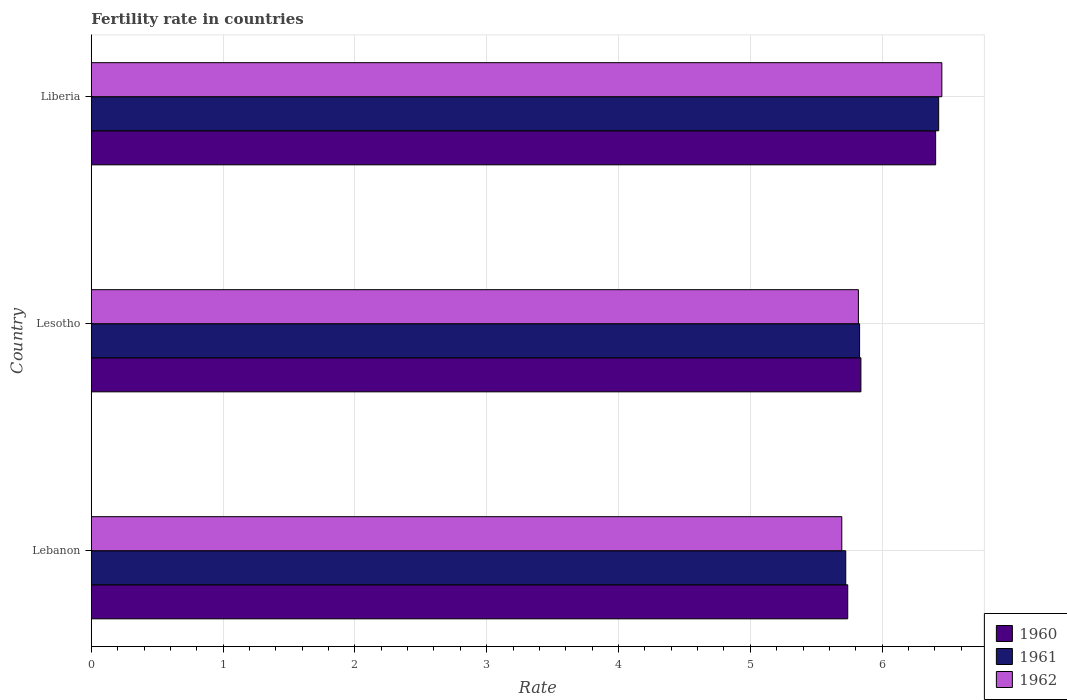How many different coloured bars are there?
Ensure brevity in your answer.  3. How many groups of bars are there?
Offer a terse response. 3. Are the number of bars on each tick of the Y-axis equal?
Your response must be concise. Yes. How many bars are there on the 1st tick from the bottom?
Your answer should be very brief. 3. What is the label of the 3rd group of bars from the top?
Your answer should be compact. Lebanon. In how many cases, is the number of bars for a given country not equal to the number of legend labels?
Your response must be concise. 0. What is the fertility rate in 1961 in Liberia?
Ensure brevity in your answer.  6.43. Across all countries, what is the maximum fertility rate in 1961?
Your answer should be compact. 6.43. Across all countries, what is the minimum fertility rate in 1960?
Provide a short and direct response. 5.74. In which country was the fertility rate in 1962 maximum?
Provide a succinct answer. Liberia. In which country was the fertility rate in 1962 minimum?
Offer a terse response. Lebanon. What is the total fertility rate in 1960 in the graph?
Provide a short and direct response. 17.98. What is the difference between the fertility rate in 1962 in Lebanon and that in Lesotho?
Offer a terse response. -0.13. What is the difference between the fertility rate in 1961 in Lesotho and the fertility rate in 1960 in Lebanon?
Your answer should be very brief. 0.09. What is the average fertility rate in 1962 per country?
Keep it short and to the point. 5.99. What is the difference between the fertility rate in 1960 and fertility rate in 1962 in Lebanon?
Your answer should be very brief. 0.04. In how many countries, is the fertility rate in 1960 greater than 2 ?
Ensure brevity in your answer.  3. What is the ratio of the fertility rate in 1960 in Lebanon to that in Liberia?
Keep it short and to the point. 0.9. Is the fertility rate in 1962 in Lesotho less than that in Liberia?
Offer a terse response. Yes. What is the difference between the highest and the second highest fertility rate in 1960?
Your answer should be very brief. 0.57. What is the difference between the highest and the lowest fertility rate in 1961?
Make the answer very short. 0.7. Is the sum of the fertility rate in 1961 in Lebanon and Liberia greater than the maximum fertility rate in 1960 across all countries?
Offer a very short reply. Yes. What does the 2nd bar from the top in Lebanon represents?
Give a very brief answer. 1961. What does the 1st bar from the bottom in Liberia represents?
Offer a terse response. 1960. Is it the case that in every country, the sum of the fertility rate in 1960 and fertility rate in 1962 is greater than the fertility rate in 1961?
Offer a very short reply. Yes. How many bars are there?
Your answer should be compact. 9. Are all the bars in the graph horizontal?
Make the answer very short. Yes. How many countries are there in the graph?
Your response must be concise. 3. Does the graph contain any zero values?
Ensure brevity in your answer.  No. How are the legend labels stacked?
Provide a succinct answer. Vertical. What is the title of the graph?
Offer a very short reply. Fertility rate in countries. What is the label or title of the X-axis?
Your answer should be very brief. Rate. What is the label or title of the Y-axis?
Make the answer very short. Country. What is the Rate of 1960 in Lebanon?
Keep it short and to the point. 5.74. What is the Rate of 1961 in Lebanon?
Your answer should be very brief. 5.72. What is the Rate in 1962 in Lebanon?
Your answer should be very brief. 5.69. What is the Rate of 1960 in Lesotho?
Make the answer very short. 5.84. What is the Rate in 1961 in Lesotho?
Provide a succinct answer. 5.83. What is the Rate in 1962 in Lesotho?
Provide a succinct answer. 5.82. What is the Rate of 1960 in Liberia?
Offer a very short reply. 6.41. What is the Rate in 1961 in Liberia?
Offer a terse response. 6.43. What is the Rate of 1962 in Liberia?
Make the answer very short. 6.45. Across all countries, what is the maximum Rate in 1960?
Provide a short and direct response. 6.41. Across all countries, what is the maximum Rate of 1961?
Your answer should be very brief. 6.43. Across all countries, what is the maximum Rate of 1962?
Provide a succinct answer. 6.45. Across all countries, what is the minimum Rate of 1960?
Provide a short and direct response. 5.74. Across all countries, what is the minimum Rate of 1961?
Your answer should be compact. 5.72. Across all countries, what is the minimum Rate in 1962?
Provide a short and direct response. 5.69. What is the total Rate in 1960 in the graph?
Give a very brief answer. 17.98. What is the total Rate of 1961 in the graph?
Offer a very short reply. 17.98. What is the total Rate in 1962 in the graph?
Ensure brevity in your answer.  17.97. What is the difference between the Rate of 1960 in Lebanon and that in Lesotho?
Provide a short and direct response. -0.1. What is the difference between the Rate in 1961 in Lebanon and that in Lesotho?
Provide a short and direct response. -0.1. What is the difference between the Rate of 1962 in Lebanon and that in Lesotho?
Provide a succinct answer. -0.13. What is the difference between the Rate in 1960 in Lebanon and that in Liberia?
Offer a terse response. -0.67. What is the difference between the Rate in 1961 in Lebanon and that in Liberia?
Offer a terse response. -0.7. What is the difference between the Rate in 1962 in Lebanon and that in Liberia?
Keep it short and to the point. -0.76. What is the difference between the Rate in 1960 in Lesotho and that in Liberia?
Provide a short and direct response. -0.57. What is the difference between the Rate in 1961 in Lesotho and that in Liberia?
Ensure brevity in your answer.  -0.6. What is the difference between the Rate in 1962 in Lesotho and that in Liberia?
Offer a very short reply. -0.63. What is the difference between the Rate of 1960 in Lebanon and the Rate of 1961 in Lesotho?
Keep it short and to the point. -0.09. What is the difference between the Rate in 1960 in Lebanon and the Rate in 1962 in Lesotho?
Keep it short and to the point. -0.08. What is the difference between the Rate of 1961 in Lebanon and the Rate of 1962 in Lesotho?
Offer a terse response. -0.1. What is the difference between the Rate of 1960 in Lebanon and the Rate of 1961 in Liberia?
Ensure brevity in your answer.  -0.69. What is the difference between the Rate of 1960 in Lebanon and the Rate of 1962 in Liberia?
Offer a terse response. -0.71. What is the difference between the Rate of 1961 in Lebanon and the Rate of 1962 in Liberia?
Ensure brevity in your answer.  -0.73. What is the difference between the Rate in 1960 in Lesotho and the Rate in 1961 in Liberia?
Offer a terse response. -0.59. What is the difference between the Rate of 1960 in Lesotho and the Rate of 1962 in Liberia?
Provide a short and direct response. -0.61. What is the difference between the Rate in 1961 in Lesotho and the Rate in 1962 in Liberia?
Ensure brevity in your answer.  -0.62. What is the average Rate in 1960 per country?
Offer a very short reply. 5.99. What is the average Rate in 1961 per country?
Offer a very short reply. 5.99. What is the average Rate of 1962 per country?
Ensure brevity in your answer.  5.99. What is the difference between the Rate in 1960 and Rate in 1961 in Lebanon?
Provide a short and direct response. 0.01. What is the difference between the Rate in 1960 and Rate in 1962 in Lebanon?
Your answer should be compact. 0.04. What is the difference between the Rate of 1960 and Rate of 1962 in Lesotho?
Give a very brief answer. 0.02. What is the difference between the Rate in 1961 and Rate in 1962 in Lesotho?
Provide a succinct answer. 0.01. What is the difference between the Rate in 1960 and Rate in 1961 in Liberia?
Offer a terse response. -0.02. What is the difference between the Rate in 1960 and Rate in 1962 in Liberia?
Provide a succinct answer. -0.05. What is the difference between the Rate of 1961 and Rate of 1962 in Liberia?
Offer a very short reply. -0.02. What is the ratio of the Rate of 1960 in Lebanon to that in Lesotho?
Ensure brevity in your answer.  0.98. What is the ratio of the Rate of 1962 in Lebanon to that in Lesotho?
Your answer should be very brief. 0.98. What is the ratio of the Rate in 1960 in Lebanon to that in Liberia?
Your response must be concise. 0.9. What is the ratio of the Rate in 1961 in Lebanon to that in Liberia?
Offer a terse response. 0.89. What is the ratio of the Rate of 1962 in Lebanon to that in Liberia?
Your response must be concise. 0.88. What is the ratio of the Rate in 1960 in Lesotho to that in Liberia?
Provide a succinct answer. 0.91. What is the ratio of the Rate in 1961 in Lesotho to that in Liberia?
Give a very brief answer. 0.91. What is the ratio of the Rate in 1962 in Lesotho to that in Liberia?
Offer a very short reply. 0.9. What is the difference between the highest and the second highest Rate of 1960?
Provide a succinct answer. 0.57. What is the difference between the highest and the second highest Rate in 1961?
Your response must be concise. 0.6. What is the difference between the highest and the second highest Rate in 1962?
Keep it short and to the point. 0.63. What is the difference between the highest and the lowest Rate in 1960?
Your answer should be compact. 0.67. What is the difference between the highest and the lowest Rate in 1961?
Make the answer very short. 0.7. What is the difference between the highest and the lowest Rate of 1962?
Provide a short and direct response. 0.76. 